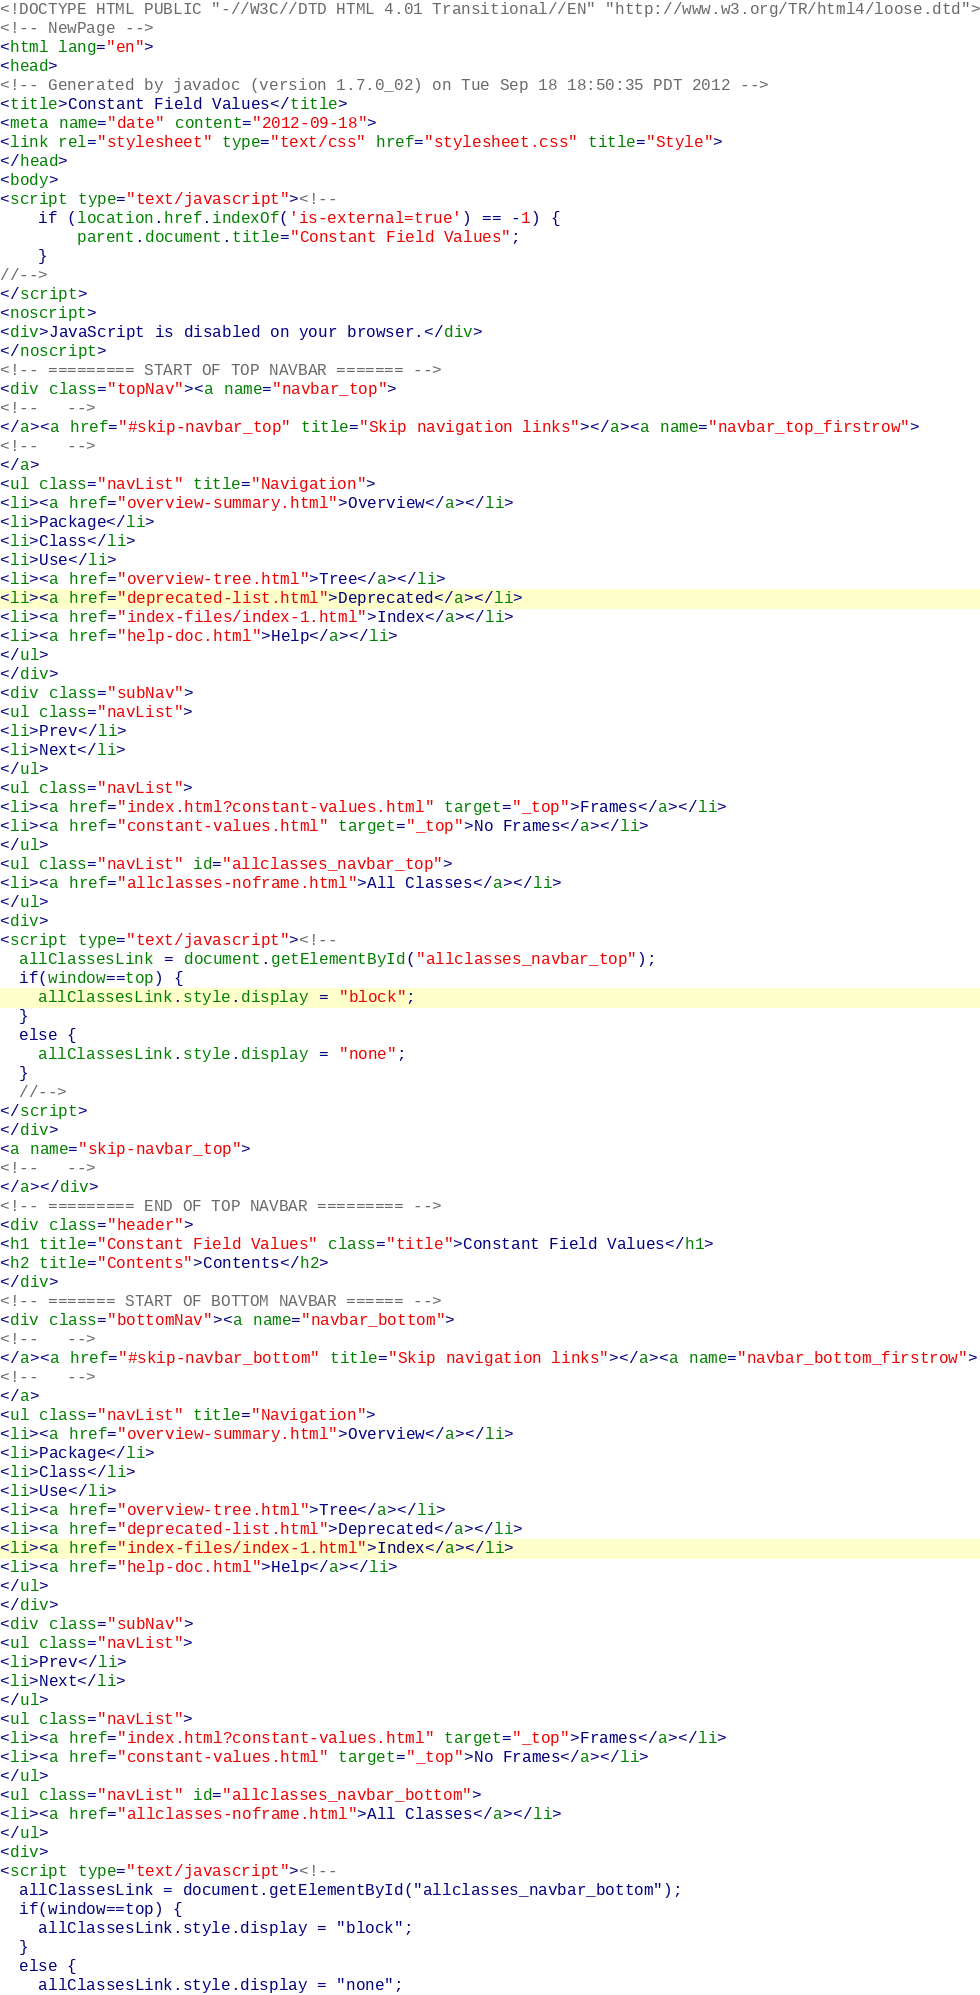Convert code to text. <code><loc_0><loc_0><loc_500><loc_500><_HTML_><!DOCTYPE HTML PUBLIC "-//W3C//DTD HTML 4.01 Transitional//EN" "http://www.w3.org/TR/html4/loose.dtd">
<!-- NewPage -->
<html lang="en">
<head>
<!-- Generated by javadoc (version 1.7.0_02) on Tue Sep 18 18:50:35 PDT 2012 -->
<title>Constant Field Values</title>
<meta name="date" content="2012-09-18">
<link rel="stylesheet" type="text/css" href="stylesheet.css" title="Style">
</head>
<body>
<script type="text/javascript"><!--
    if (location.href.indexOf('is-external=true') == -1) {
        parent.document.title="Constant Field Values";
    }
//-->
</script>
<noscript>
<div>JavaScript is disabled on your browser.</div>
</noscript>
<!-- ========= START OF TOP NAVBAR ======= -->
<div class="topNav"><a name="navbar_top">
<!--   -->
</a><a href="#skip-navbar_top" title="Skip navigation links"></a><a name="navbar_top_firstrow">
<!--   -->
</a>
<ul class="navList" title="Navigation">
<li><a href="overview-summary.html">Overview</a></li>
<li>Package</li>
<li>Class</li>
<li>Use</li>
<li><a href="overview-tree.html">Tree</a></li>
<li><a href="deprecated-list.html">Deprecated</a></li>
<li><a href="index-files/index-1.html">Index</a></li>
<li><a href="help-doc.html">Help</a></li>
</ul>
</div>
<div class="subNav">
<ul class="navList">
<li>Prev</li>
<li>Next</li>
</ul>
<ul class="navList">
<li><a href="index.html?constant-values.html" target="_top">Frames</a></li>
<li><a href="constant-values.html" target="_top">No Frames</a></li>
</ul>
<ul class="navList" id="allclasses_navbar_top">
<li><a href="allclasses-noframe.html">All Classes</a></li>
</ul>
<div>
<script type="text/javascript"><!--
  allClassesLink = document.getElementById("allclasses_navbar_top");
  if(window==top) {
    allClassesLink.style.display = "block";
  }
  else {
    allClassesLink.style.display = "none";
  }
  //-->
</script>
</div>
<a name="skip-navbar_top">
<!--   -->
</a></div>
<!-- ========= END OF TOP NAVBAR ========= -->
<div class="header">
<h1 title="Constant Field Values" class="title">Constant Field Values</h1>
<h2 title="Contents">Contents</h2>
</div>
<!-- ======= START OF BOTTOM NAVBAR ====== -->
<div class="bottomNav"><a name="navbar_bottom">
<!--   -->
</a><a href="#skip-navbar_bottom" title="Skip navigation links"></a><a name="navbar_bottom_firstrow">
<!--   -->
</a>
<ul class="navList" title="Navigation">
<li><a href="overview-summary.html">Overview</a></li>
<li>Package</li>
<li>Class</li>
<li>Use</li>
<li><a href="overview-tree.html">Tree</a></li>
<li><a href="deprecated-list.html">Deprecated</a></li>
<li><a href="index-files/index-1.html">Index</a></li>
<li><a href="help-doc.html">Help</a></li>
</ul>
</div>
<div class="subNav">
<ul class="navList">
<li>Prev</li>
<li>Next</li>
</ul>
<ul class="navList">
<li><a href="index.html?constant-values.html" target="_top">Frames</a></li>
<li><a href="constant-values.html" target="_top">No Frames</a></li>
</ul>
<ul class="navList" id="allclasses_navbar_bottom">
<li><a href="allclasses-noframe.html">All Classes</a></li>
</ul>
<div>
<script type="text/javascript"><!--
  allClassesLink = document.getElementById("allclasses_navbar_bottom");
  if(window==top) {
    allClassesLink.style.display = "block";
  }
  else {
    allClassesLink.style.display = "none";</code> 